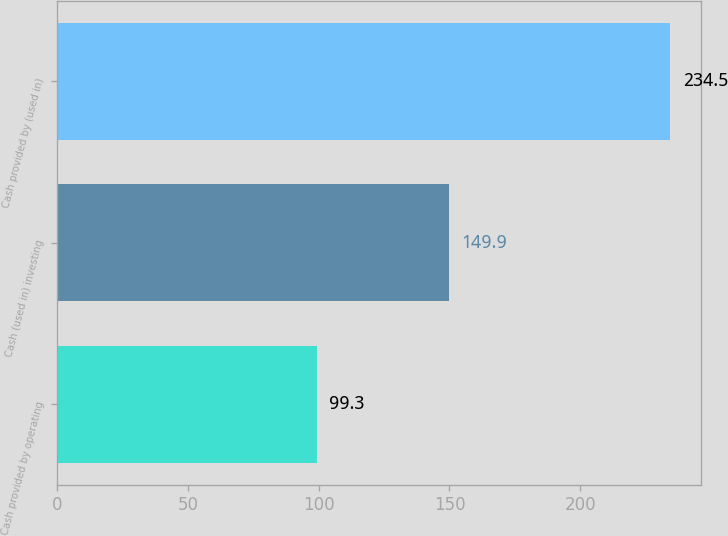<chart> <loc_0><loc_0><loc_500><loc_500><bar_chart><fcel>Cash provided by operating<fcel>Cash (used in) investing<fcel>Cash provided by (used in)<nl><fcel>99.3<fcel>149.9<fcel>234.5<nl></chart> 